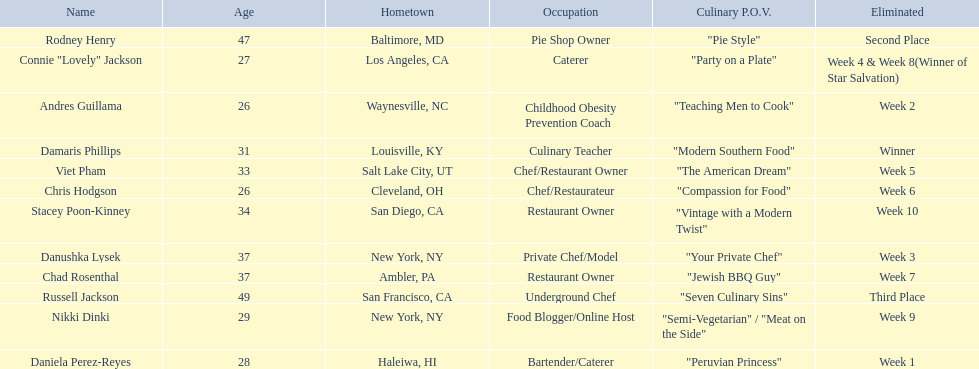Who are the contestants? Damaris Phillips, 31, Rodney Henry, 47, Russell Jackson, 49, Stacey Poon-Kinney, 34, Nikki Dinki, 29, Chad Rosenthal, 37, Chris Hodgson, 26, Viet Pham, 33, Connie "Lovely" Jackson, 27, Danushka Lysek, 37, Andres Guillama, 26, Daniela Perez-Reyes, 28. How old is chris hodgson? 26. Which other contestant has that age? Andres Guillama. 